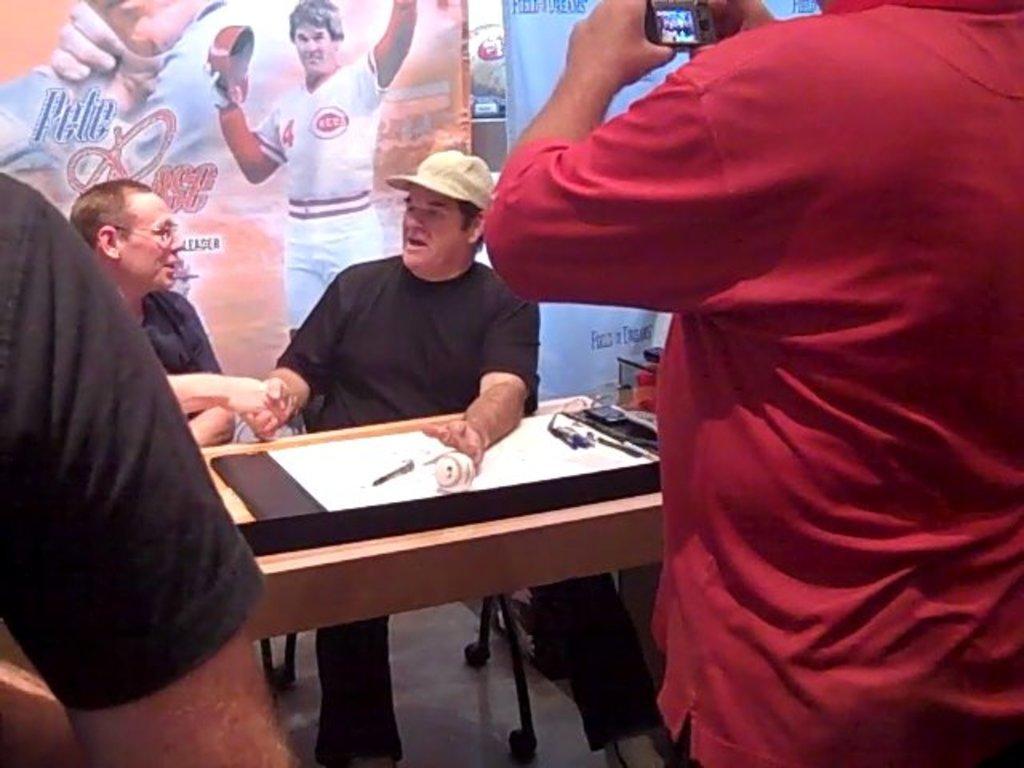Describe this image in one or two sentences. in this picture we can see a person is sitting on a chair, and beside him a man is sitting, and in front there is the table and some objects on it, and in front a person is standing on the floor and holding a camera in his hand, and at back there are some posters. 